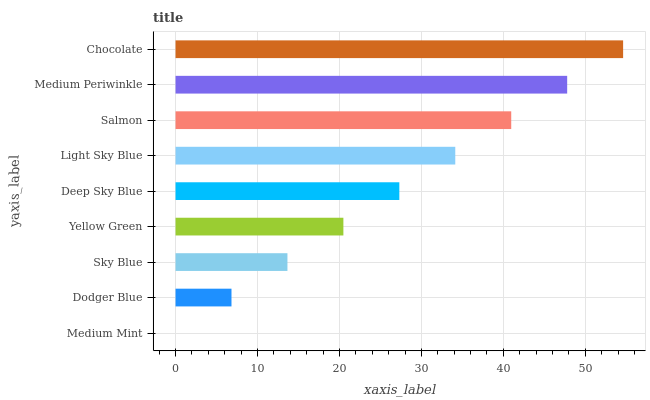Is Medium Mint the minimum?
Answer yes or no. Yes. Is Chocolate the maximum?
Answer yes or no. Yes. Is Dodger Blue the minimum?
Answer yes or no. No. Is Dodger Blue the maximum?
Answer yes or no. No. Is Dodger Blue greater than Medium Mint?
Answer yes or no. Yes. Is Medium Mint less than Dodger Blue?
Answer yes or no. Yes. Is Medium Mint greater than Dodger Blue?
Answer yes or no. No. Is Dodger Blue less than Medium Mint?
Answer yes or no. No. Is Deep Sky Blue the high median?
Answer yes or no. Yes. Is Deep Sky Blue the low median?
Answer yes or no. Yes. Is Yellow Green the high median?
Answer yes or no. No. Is Yellow Green the low median?
Answer yes or no. No. 